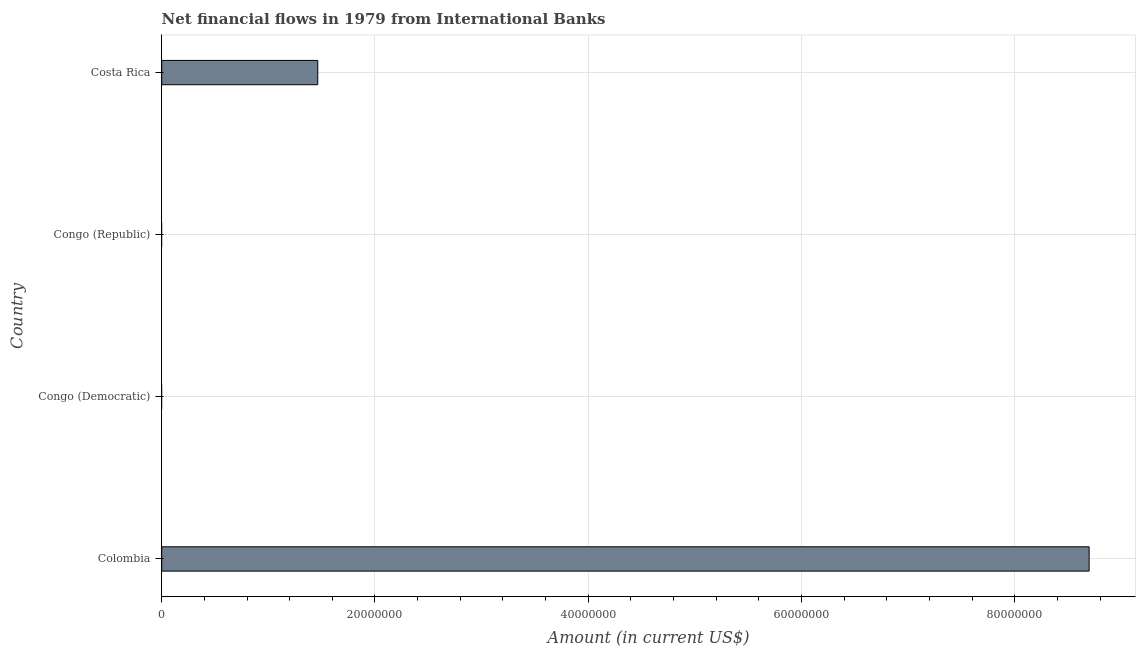Does the graph contain grids?
Your response must be concise. Yes. What is the title of the graph?
Your answer should be compact. Net financial flows in 1979 from International Banks. What is the label or title of the X-axis?
Provide a succinct answer. Amount (in current US$). What is the net financial flows from ibrd in Congo (Democratic)?
Your answer should be compact. 0. Across all countries, what is the maximum net financial flows from ibrd?
Provide a short and direct response. 8.70e+07. Across all countries, what is the minimum net financial flows from ibrd?
Your response must be concise. 0. What is the sum of the net financial flows from ibrd?
Keep it short and to the point. 1.02e+08. What is the difference between the net financial flows from ibrd in Colombia and Costa Rica?
Provide a short and direct response. 7.23e+07. What is the average net financial flows from ibrd per country?
Keep it short and to the point. 2.54e+07. What is the median net financial flows from ibrd?
Make the answer very short. 7.32e+06. In how many countries, is the net financial flows from ibrd greater than 48000000 US$?
Provide a succinct answer. 1. Is the sum of the net financial flows from ibrd in Colombia and Costa Rica greater than the maximum net financial flows from ibrd across all countries?
Your answer should be very brief. Yes. What is the difference between the highest and the lowest net financial flows from ibrd?
Your answer should be very brief. 8.70e+07. In how many countries, is the net financial flows from ibrd greater than the average net financial flows from ibrd taken over all countries?
Provide a short and direct response. 1. What is the difference between two consecutive major ticks on the X-axis?
Offer a very short reply. 2.00e+07. Are the values on the major ticks of X-axis written in scientific E-notation?
Keep it short and to the point. No. What is the Amount (in current US$) of Colombia?
Offer a terse response. 8.70e+07. What is the Amount (in current US$) in Congo (Democratic)?
Offer a terse response. 0. What is the Amount (in current US$) of Costa Rica?
Keep it short and to the point. 1.46e+07. What is the difference between the Amount (in current US$) in Colombia and Costa Rica?
Give a very brief answer. 7.23e+07. What is the ratio of the Amount (in current US$) in Colombia to that in Costa Rica?
Keep it short and to the point. 5.94. 